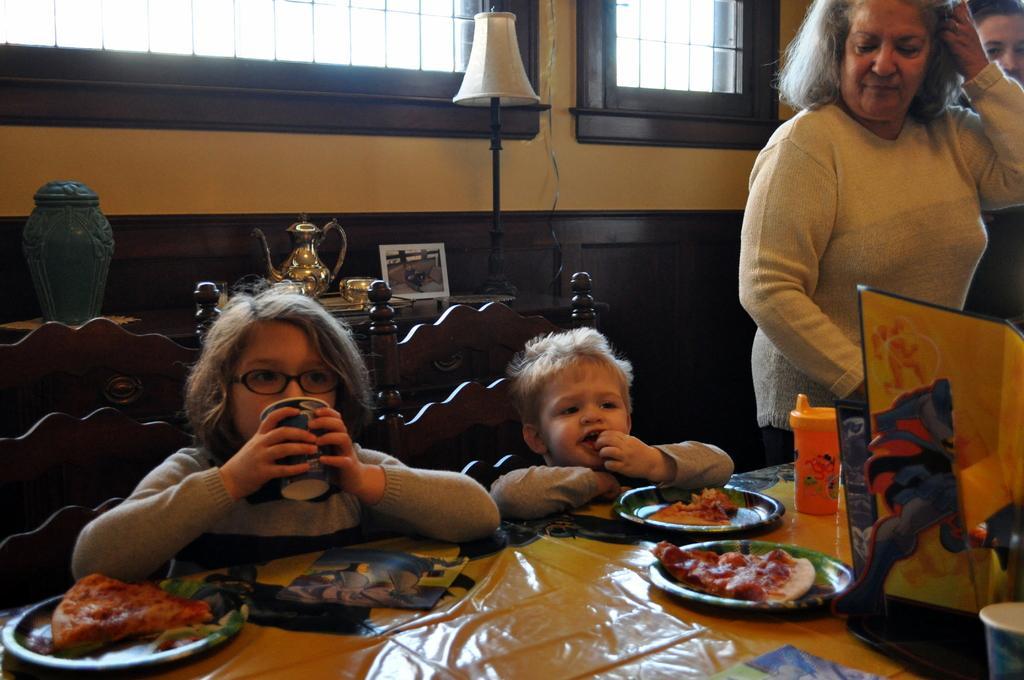Please provide a concise description of this image. In this image I can see women and two children. The two children are sitting on a chair in front of a table. On the table I can see few objects on it. 